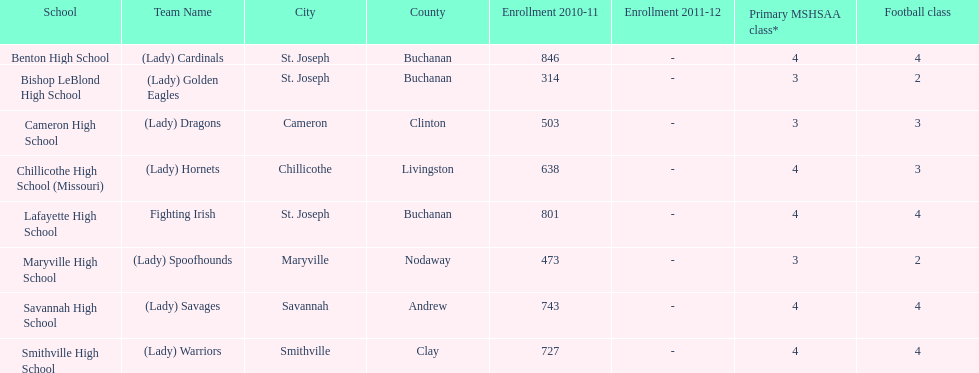How many schools are there in this conference? 8. Could you help me parse every detail presented in this table? {'header': ['School', 'Team Name', 'City', 'County', 'Enrollment 2010-11', 'Enrollment 2011-12', 'Primary MSHSAA class*', 'Football class'], 'rows': [['Benton High School', '(Lady) Cardinals', 'St. Joseph', 'Buchanan', '846', '-', '4', '4'], ['Bishop LeBlond High School', '(Lady) Golden Eagles', 'St. Joseph', 'Buchanan', '314', '-', '3', '2'], ['Cameron High School', '(Lady) Dragons', 'Cameron', 'Clinton', '503', '-', '3', '3'], ['Chillicothe High School (Missouri)', '(Lady) Hornets', 'Chillicothe', 'Livingston', '638', '-', '4', '3'], ['Lafayette High School', 'Fighting Irish', 'St. Joseph', 'Buchanan', '801', '-', '4', '4'], ['Maryville High School', '(Lady) Spoofhounds', 'Maryville', 'Nodaway', '473', '-', '3', '2'], ['Savannah High School', '(Lady) Savages', 'Savannah', 'Andrew', '743', '-', '4', '4'], ['Smithville High School', '(Lady) Warriors', 'Smithville', 'Clay', '727', '-', '4', '4']]} 